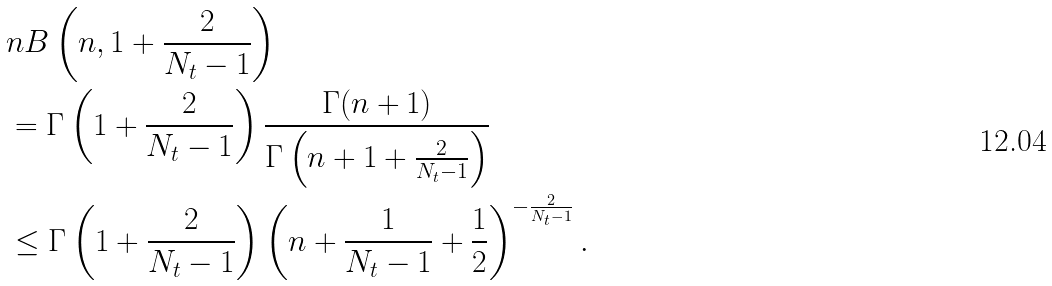<formula> <loc_0><loc_0><loc_500><loc_500>& n B \left ( n , 1 + \frac { 2 } { N _ { t } - 1 } \right ) \\ & = \Gamma \left ( 1 + \frac { 2 } { N _ { t } - 1 } \right ) \frac { \Gamma ( n + 1 ) } { \Gamma \left ( n + 1 + \frac { 2 } { N _ { t } - 1 } \right ) } \\ & \leq \Gamma \left ( 1 + \frac { 2 } { N _ { t } - 1 } \right ) \left ( n + \frac { 1 } { N _ { t } - 1 } + \frac { 1 } { 2 } \right ) ^ { - \frac { 2 } { N _ { t } - 1 } } .</formula> 